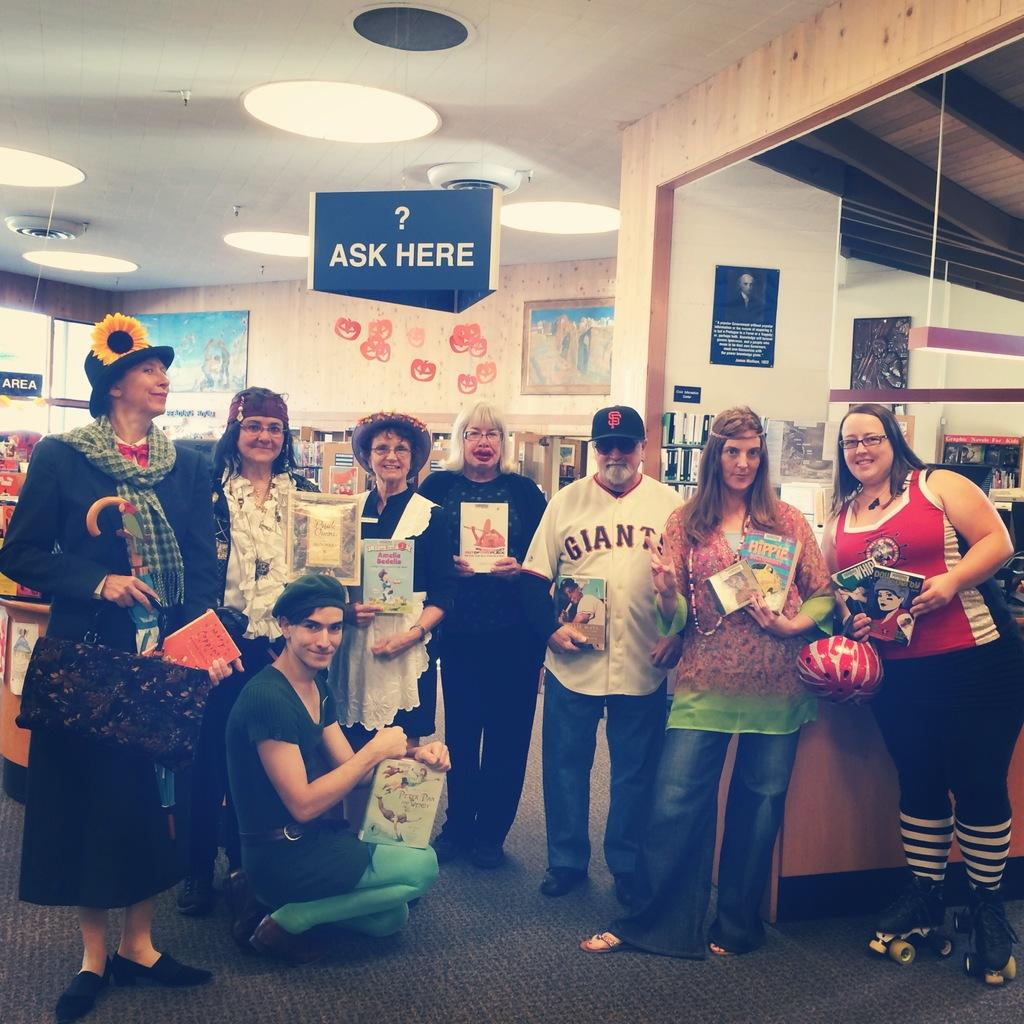<image>
Provide a brief description of the given image. Several people inside a store are lined up and holding their books and one man has a Giants jersey on. 